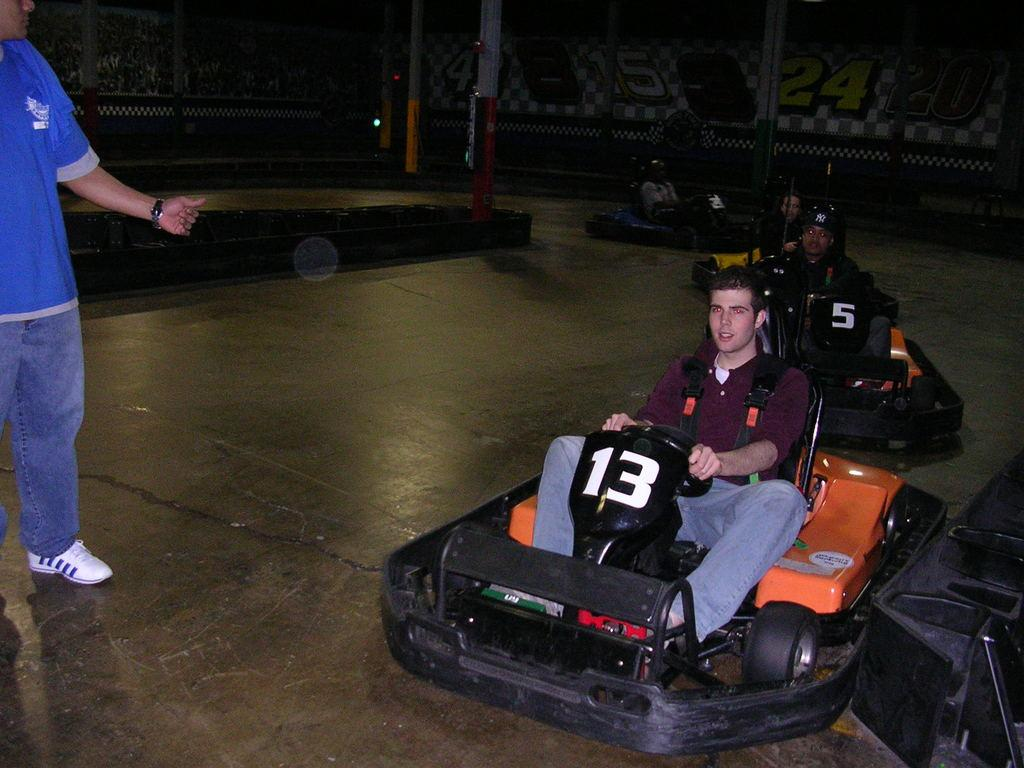What are the persons in the image doing? The persons in the image are riding a car. Can you describe the position of the other person in the image? There is one person standing. What type of bed can be seen in the image? There is no bed present in the image. Is the person standing reading a book in the image? There is no book or indication of reading in the image. 